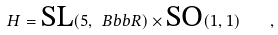Convert formula to latex. <formula><loc_0><loc_0><loc_500><loc_500>H = \text {SL} ( 5 , \ B b b { R } ) \times \text {SO} ( 1 , 1 ) \quad ,</formula> 